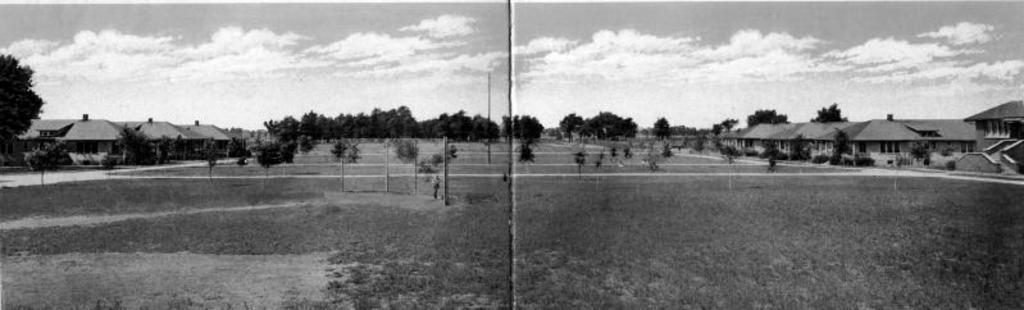What is the color scheme of the image? The image is black and white. What type of artwork is depicted in the image? There is a collage in the image. What structures can be seen in the image? Buildings are present in the image. What type of natural elements are visible in the image? Trees are visible in the image. What is visible in the background of the image? The sky is visible in the background of the image. What can be seen in the sky? Clouds are present in the sky. What type of powder is being used to create the collage in the image? There is no indication of any powder being used in the image; it is a black and white collage featuring buildings, trees, and clouds. What book is being referenced in the collage? There is no book present in the collage or the image. 